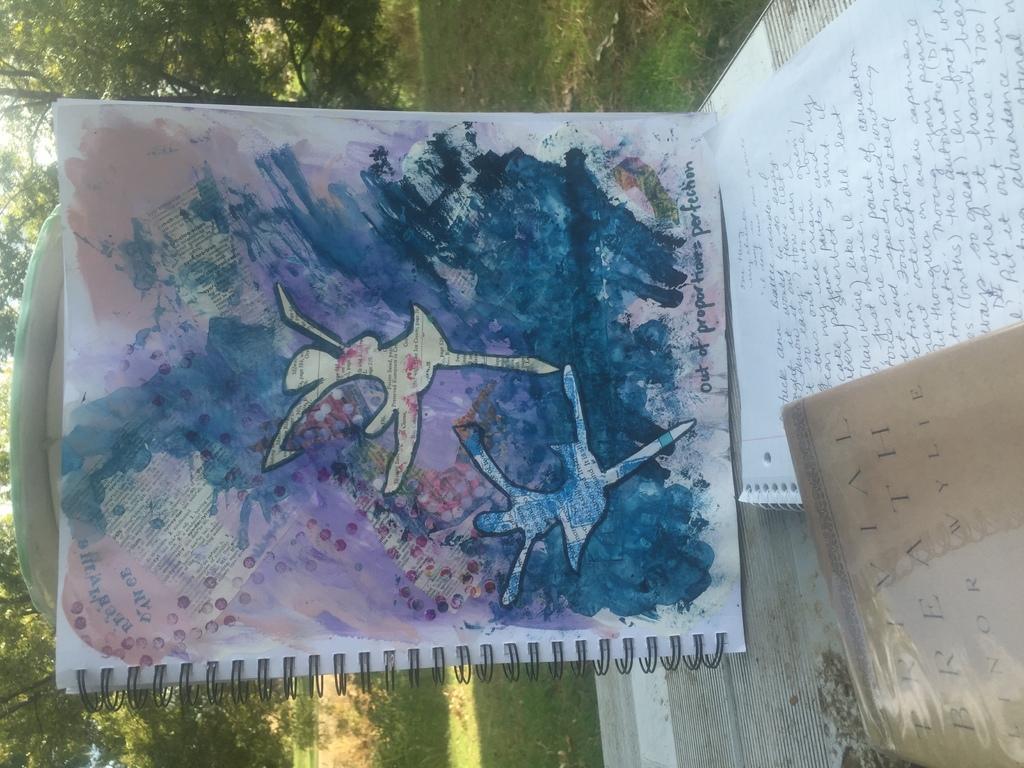Please provide a concise description of this image. In the middle it is a book, there is a water a painting on it, there are two girls dancing in it. 